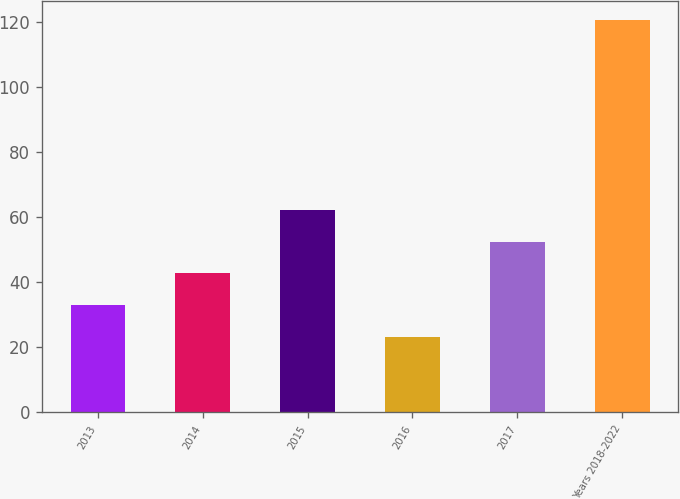Convert chart to OTSL. <chart><loc_0><loc_0><loc_500><loc_500><bar_chart><fcel>2013<fcel>2014<fcel>2015<fcel>2016<fcel>2017<fcel>Years 2018-2022<nl><fcel>33.02<fcel>42.74<fcel>62.18<fcel>23.3<fcel>52.46<fcel>120.5<nl></chart> 